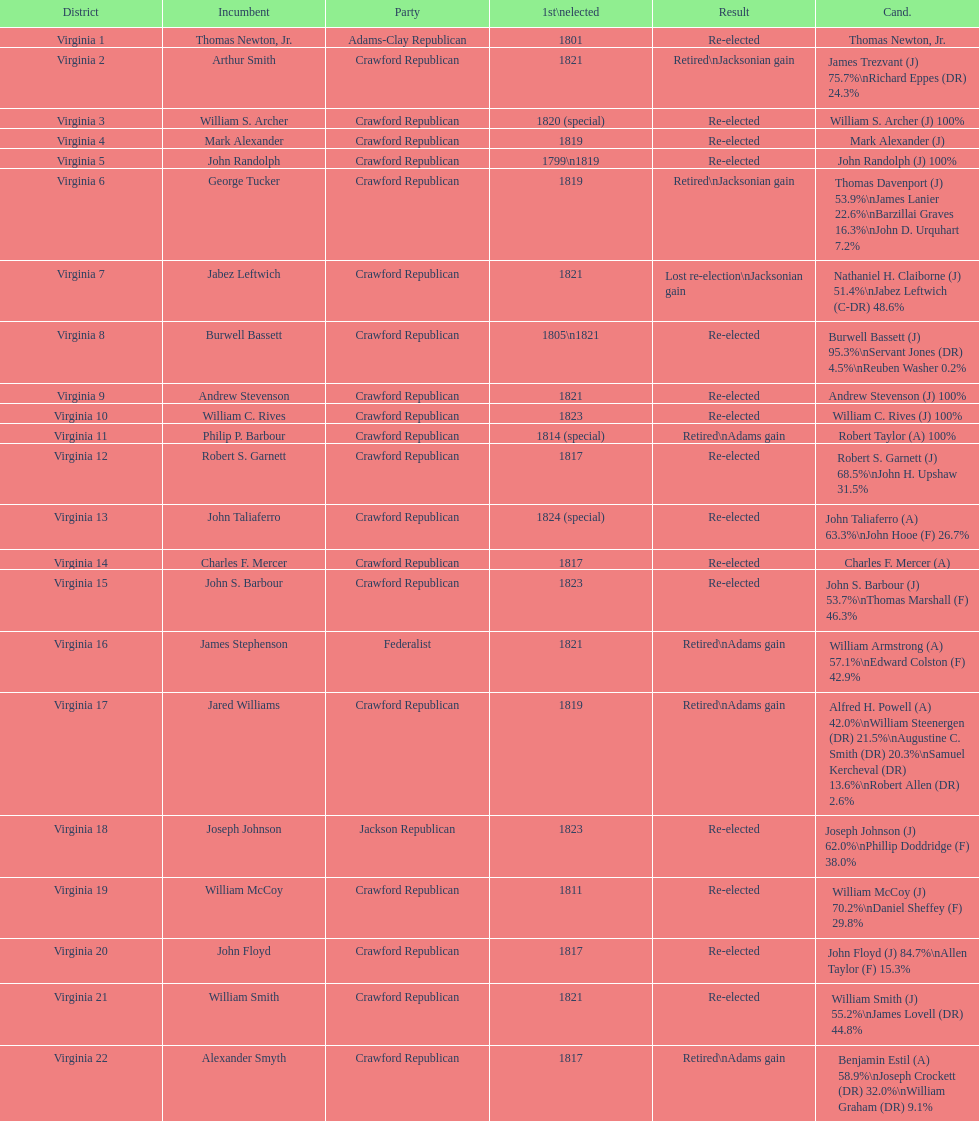Who were the incumbents of the 1824 united states house of representatives elections? Thomas Newton, Jr., Arthur Smith, William S. Archer, Mark Alexander, John Randolph, George Tucker, Jabez Leftwich, Burwell Bassett, Andrew Stevenson, William C. Rives, Philip P. Barbour, Robert S. Garnett, John Taliaferro, Charles F. Mercer, John S. Barbour, James Stephenson, Jared Williams, Joseph Johnson, William McCoy, John Floyd, William Smith, Alexander Smyth. And who were the candidates? Thomas Newton, Jr., James Trezvant (J) 75.7%\nRichard Eppes (DR) 24.3%, William S. Archer (J) 100%, Mark Alexander (J), John Randolph (J) 100%, Thomas Davenport (J) 53.9%\nJames Lanier 22.6%\nBarzillai Graves 16.3%\nJohn D. Urquhart 7.2%, Nathaniel H. Claiborne (J) 51.4%\nJabez Leftwich (C-DR) 48.6%, Burwell Bassett (J) 95.3%\nServant Jones (DR) 4.5%\nReuben Washer 0.2%, Andrew Stevenson (J) 100%, William C. Rives (J) 100%, Robert Taylor (A) 100%, Robert S. Garnett (J) 68.5%\nJohn H. Upshaw 31.5%, John Taliaferro (A) 63.3%\nJohn Hooe (F) 26.7%, Charles F. Mercer (A), John S. Barbour (J) 53.7%\nThomas Marshall (F) 46.3%, William Armstrong (A) 57.1%\nEdward Colston (F) 42.9%, Alfred H. Powell (A) 42.0%\nWilliam Steenergen (DR) 21.5%\nAugustine C. Smith (DR) 20.3%\nSamuel Kercheval (DR) 13.6%\nRobert Allen (DR) 2.6%, Joseph Johnson (J) 62.0%\nPhillip Doddridge (F) 38.0%, William McCoy (J) 70.2%\nDaniel Sheffey (F) 29.8%, John Floyd (J) 84.7%\nAllen Taylor (F) 15.3%, William Smith (J) 55.2%\nJames Lovell (DR) 44.8%, Benjamin Estil (A) 58.9%\nJoseph Crockett (DR) 32.0%\nWilliam Graham (DR) 9.1%. What were the results of their elections? Re-elected, Retired\nJacksonian gain, Re-elected, Re-elected, Re-elected, Retired\nJacksonian gain, Lost re-election\nJacksonian gain, Re-elected, Re-elected, Re-elected, Retired\nAdams gain, Re-elected, Re-elected, Re-elected, Re-elected, Retired\nAdams gain, Retired\nAdams gain, Re-elected, Re-elected, Re-elected, Re-elected, Retired\nAdams gain. And which jacksonian won over 76%? Arthur Smith. 